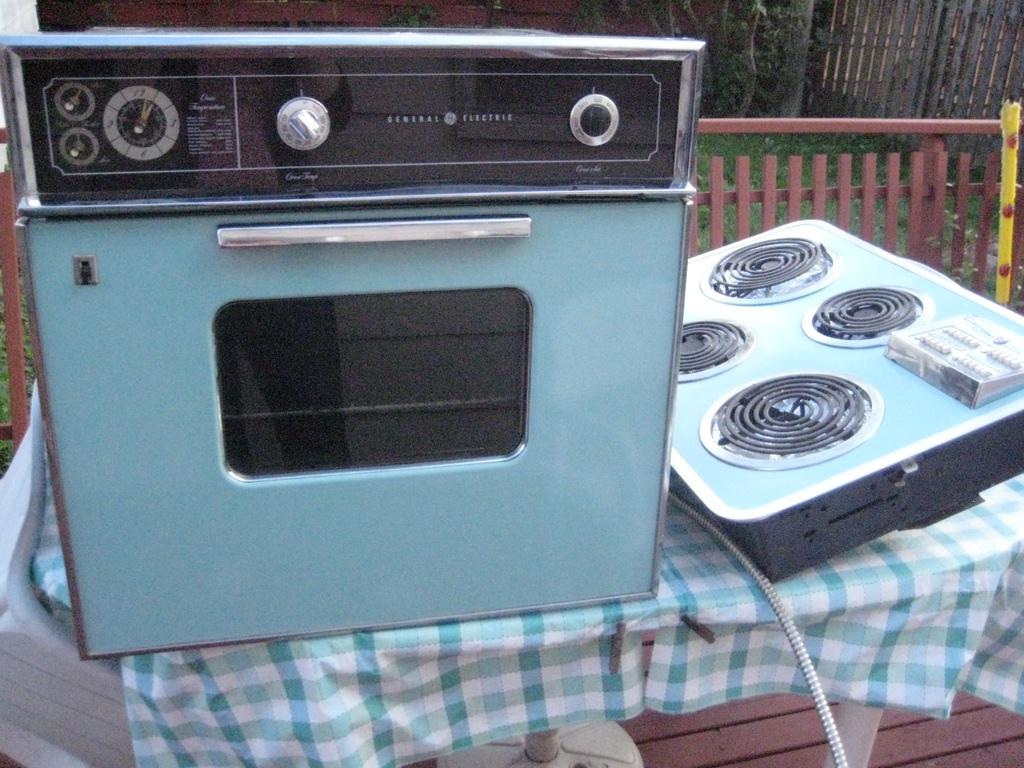What is the name written between the two buttons ?
Provide a succinct answer. General electric. Is this new?
Make the answer very short. No. 